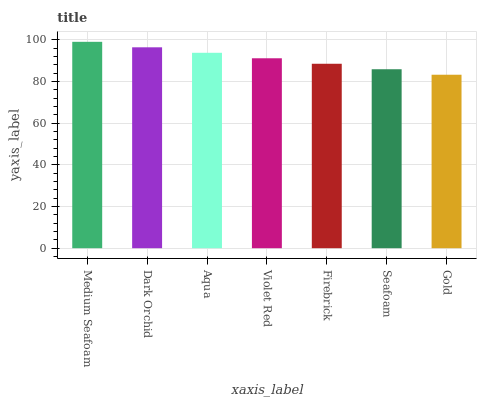Is Dark Orchid the minimum?
Answer yes or no. No. Is Dark Orchid the maximum?
Answer yes or no. No. Is Medium Seafoam greater than Dark Orchid?
Answer yes or no. Yes. Is Dark Orchid less than Medium Seafoam?
Answer yes or no. Yes. Is Dark Orchid greater than Medium Seafoam?
Answer yes or no. No. Is Medium Seafoam less than Dark Orchid?
Answer yes or no. No. Is Violet Red the high median?
Answer yes or no. Yes. Is Violet Red the low median?
Answer yes or no. Yes. Is Gold the high median?
Answer yes or no. No. Is Medium Seafoam the low median?
Answer yes or no. No. 